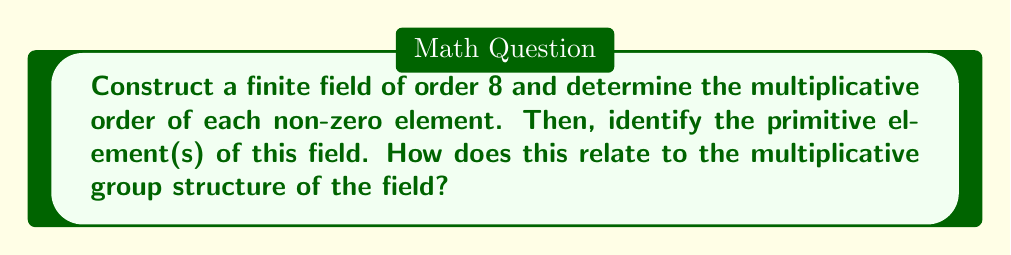Could you help me with this problem? Let's approach this step-by-step:

1) To construct a finite field of order 8, we need an irreducible polynomial of degree 3 over $\mathbb{F}_2$. Let's use $p(x) = x^3 + x + 1$.

2) The elements of the field are:
   $\{0, 1, \alpha, \alpha^2, \alpha^3, \alpha^4, \alpha^5, \alpha^6\}$
   where $\alpha$ is a root of $p(x)$.

3) We can represent these elements as polynomials:
   $0, 1, \alpha, \alpha^2, \alpha+1, \alpha^2+\alpha, \alpha^2+\alpha+1, \alpha^2+1$

4) To find the multiplicative order of each non-zero element, we need to compute powers until we reach 1:

   For $1$: $1^1 = 1$, order = 1
   
   For $\alpha$: 
   $\alpha^1 = \alpha$
   $\alpha^2 = \alpha^2$
   $\alpha^3 = \alpha + 1$
   $\alpha^4 = \alpha^2 + \alpha$
   $\alpha^5 = \alpha^2 + \alpha + 1$
   $\alpha^6 = \alpha^2 + 1$
   $\alpha^7 = 1$, order = 7
   
   For $\alpha^2$: 
   $(\alpha^2)^1 = \alpha^2$
   $(\alpha^2)^2 = \alpha + 1$
   $(\alpha^2)^3 = \alpha^2 + 1$
   $(\alpha^2)^4 = 1$, order = 4
   
   For $\alpha + 1$: 
   $(\alpha + 1)^1 = \alpha + 1$
   $(\alpha + 1)^2 = \alpha^2 + 1$
   $(\alpha + 1)^3 = \alpha^2 + \alpha$
   $(\alpha + 1)^4 = 1$, order = 4
   
   For $\alpha^2 + \alpha$:
   $(\alpha^2 + \alpha)^1 = \alpha^2 + \alpha$
   $(\alpha^2 + \alpha)^2 = \alpha^2 + \alpha + 1$
   $(\alpha^2 + \alpha)^3 = 1$, order = 3
   
   For $\alpha^2 + \alpha + 1$:
   $(\alpha^2 + \alpha + 1)^1 = \alpha^2 + \alpha + 1$
   $(\alpha^2 + \alpha + 1)^2 = \alpha^2$
   $(\alpha^2 + \alpha + 1)^3 = \alpha$
   $(\alpha^2 + \alpha + 1)^4 = \alpha + 1$
   $(\alpha^2 + \alpha + 1)^5 = \alpha^2 + 1$
   $(\alpha^2 + \alpha + 1)^6 = \alpha^2 + \alpha$
   $(\alpha^2 + \alpha + 1)^7 = 1$, order = 7
   
   For $\alpha^2 + 1$:
   $(\alpha^2 + 1)^1 = \alpha^2 + 1$
   $(\alpha^2 + 1)^2 = \alpha$
   $(\alpha^2 + 1)^3 = \alpha^2 + \alpha$
   $(\alpha^2 + 1)^4 = 1$, order = 4

5) The primitive elements are those with multiplicative order 7 (which is $8-1$). These are $\alpha$ and $\alpha^2 + \alpha + 1$.

6) This relates to the multiplicative group structure as follows:
   - The multiplicative group has order 7 (prime).
   - The primitive elements generate the entire multiplicative group.
   - The orders of elements divide the group order: we have elements of order 1, 3, 4, and 7.
   - This forms a cyclic group of order 7, isomorphic to $\mathbb{Z}_7^*$.
Answer: Primitive elements: $\alpha$ and $\alpha^2 + \alpha + 1$. Multiplicative group is cyclic of order 7. 